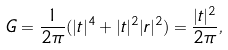Convert formula to latex. <formula><loc_0><loc_0><loc_500><loc_500>G = \frac { 1 } { 2 \pi } ( | t | ^ { 4 } + | t | ^ { 2 } | r | ^ { 2 } ) = \frac { | t | ^ { 2 } } { 2 \pi } ,</formula> 